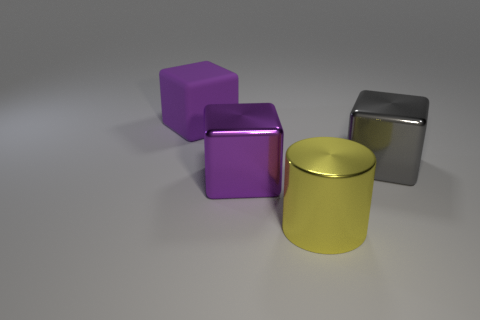Subtract all metal blocks. How many blocks are left? 1 Add 2 large cylinders. How many objects exist? 6 Subtract all cylinders. How many objects are left? 3 Subtract all purple blocks. How many blocks are left? 1 Subtract all purple cylinders. How many purple blocks are left? 2 Subtract all green blocks. Subtract all red spheres. How many blocks are left? 3 Subtract all small metal blocks. Subtract all rubber objects. How many objects are left? 3 Add 4 big shiny cylinders. How many big shiny cylinders are left? 5 Add 1 small cyan rubber cubes. How many small cyan rubber cubes exist? 1 Subtract 2 purple blocks. How many objects are left? 2 